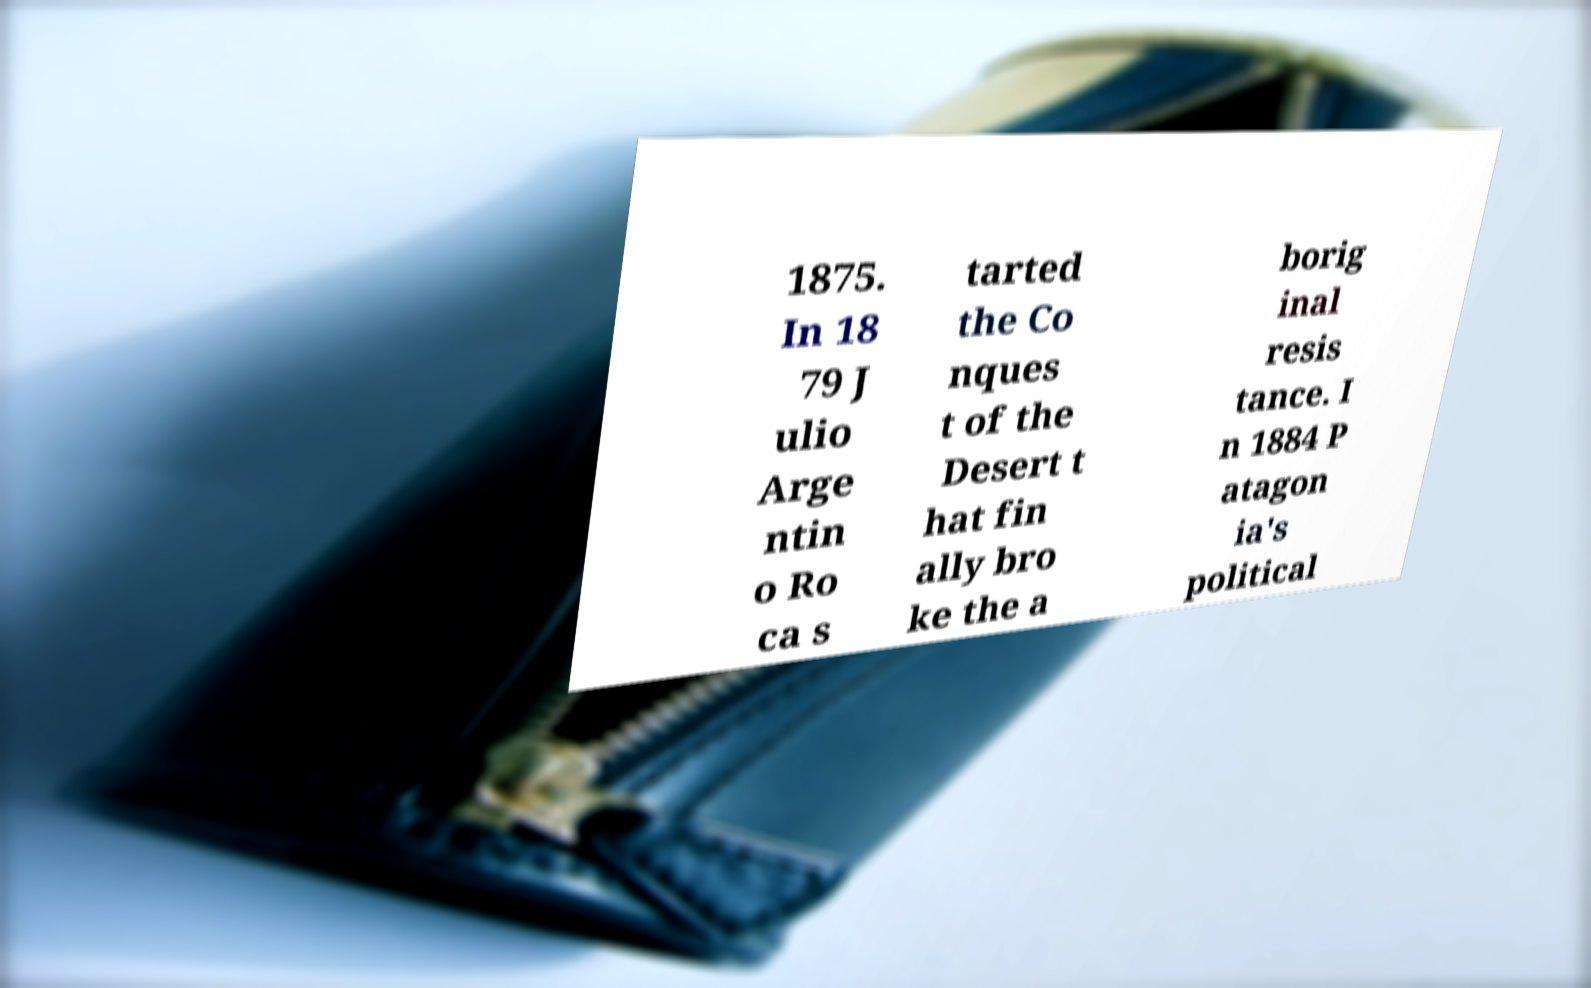Can you read and provide the text displayed in the image?This photo seems to have some interesting text. Can you extract and type it out for me? 1875. In 18 79 J ulio Arge ntin o Ro ca s tarted the Co nques t of the Desert t hat fin ally bro ke the a borig inal resis tance. I n 1884 P atagon ia's political 